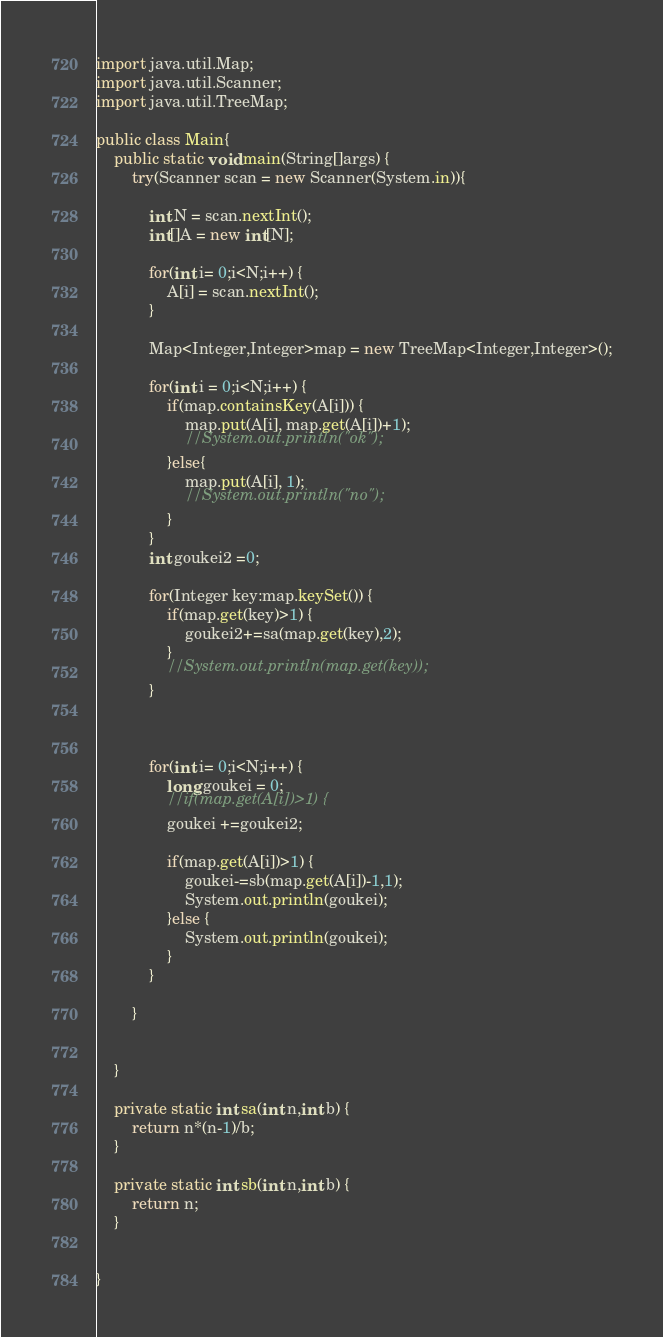Convert code to text. <code><loc_0><loc_0><loc_500><loc_500><_Java_>
import java.util.Map;
import java.util.Scanner;
import java.util.TreeMap;

public class Main{
	public static void main(String[]args) {
		try(Scanner scan = new Scanner(System.in)){
			
			int N = scan.nextInt();
			int[]A = new int[N];
			
			for(int i= 0;i<N;i++) {
				A[i] = scan.nextInt();
			}
			
			Map<Integer,Integer>map = new TreeMap<Integer,Integer>();
			
			for(int i = 0;i<N;i++) {
				if(map.containsKey(A[i])) {
					map.put(A[i], map.get(A[i])+1);
					//System.out.println("ok");
				}else{
					map.put(A[i], 1);
					//System.out.println("no");
				}
			}
			int goukei2 =0;
			
			for(Integer key:map.keySet()) {
				if(map.get(key)>1) {
					goukei2+=sa(map.get(key),2);
				}
				//System.out.println(map.get(key));
			}
			
			
			
			for(int i= 0;i<N;i++) {
				long goukei = 0;
				//if(map.get(A[i])>1) {
				goukei +=goukei2;
				
				if(map.get(A[i])>1) {
					goukei-=sb(map.get(A[i])-1,1);
					System.out.println(goukei);
				}else {
					System.out.println(goukei);
				}
			}
			
		}
		
		
	}
	
	private static int sa(int n,int b) {
		return n*(n-1)/b;
	}
	
	private static int sb(int n,int b) {
		return n;
	}
	

}
</code> 